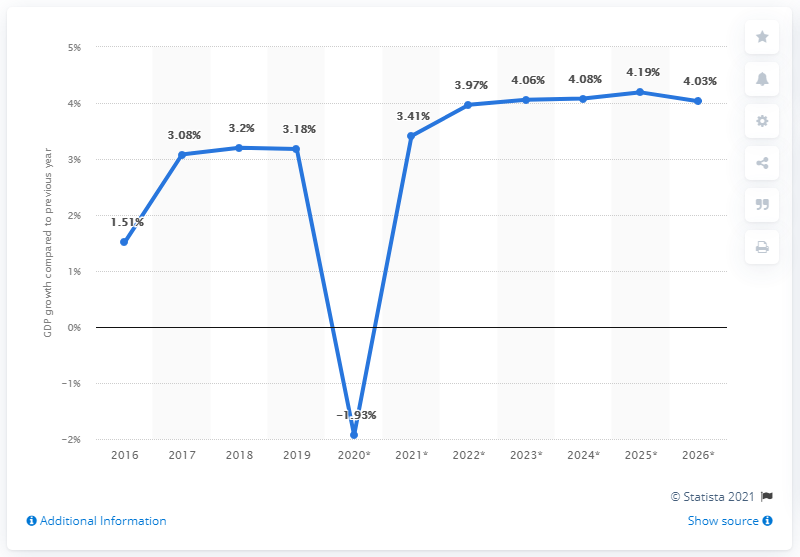Identify some key points in this picture. The growth in real GDP in Sub-Saharan Africa ended in the year 2019. The real gross domestic product in Sub-Saharan Africa grew by 3.18% in 2019. 